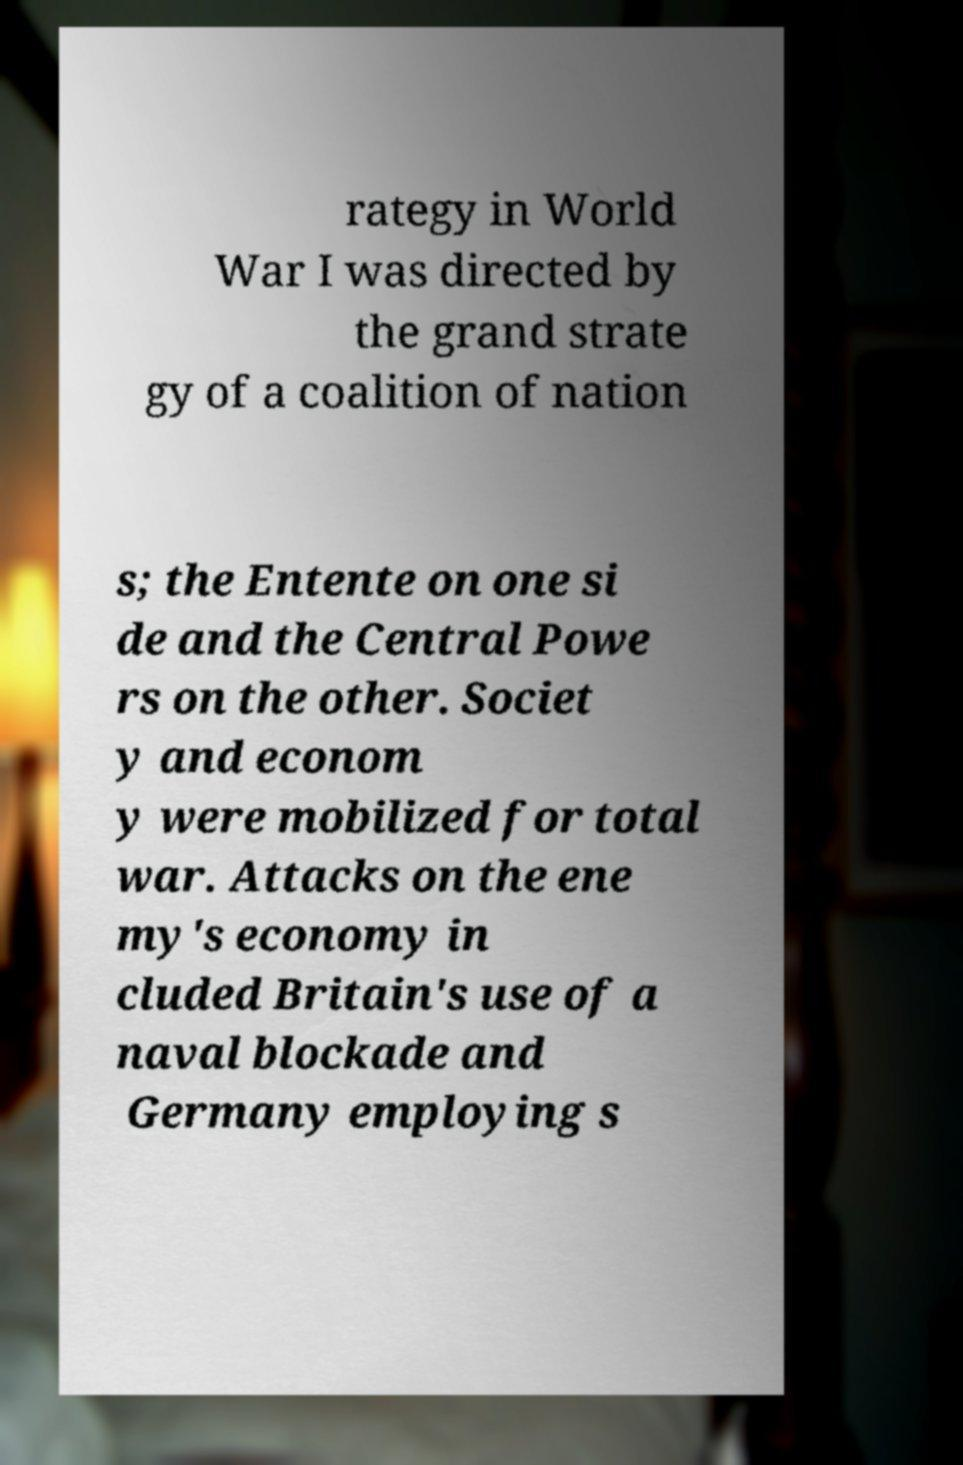Could you assist in decoding the text presented in this image and type it out clearly? rategy in World War I was directed by the grand strate gy of a coalition of nation s; the Entente on one si de and the Central Powe rs on the other. Societ y and econom y were mobilized for total war. Attacks on the ene my's economy in cluded Britain's use of a naval blockade and Germany employing s 